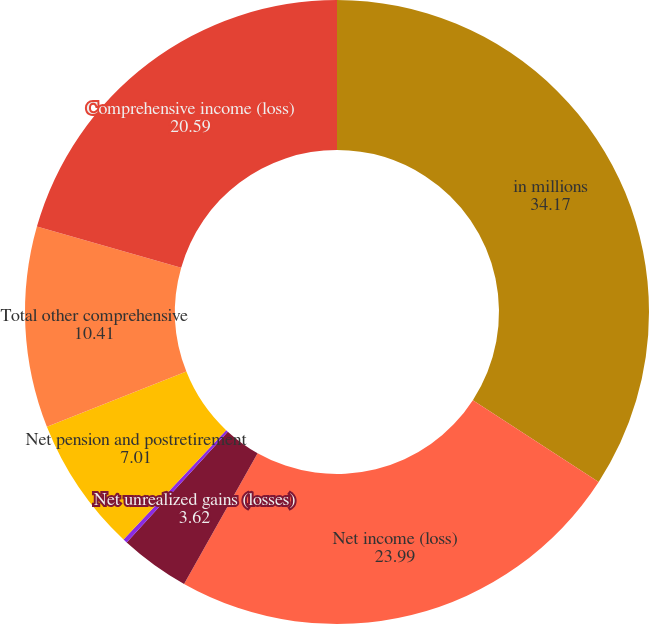Convert chart to OTSL. <chart><loc_0><loc_0><loc_500><loc_500><pie_chart><fcel>in millions<fcel>Net income (loss)<fcel>Net unrealized gains (losses)<fcel>Foreign currency translation<fcel>Net pension and postretirement<fcel>Total other comprehensive<fcel>Comprehensive income (loss)<nl><fcel>34.17%<fcel>23.99%<fcel>3.62%<fcel>0.22%<fcel>7.01%<fcel>10.41%<fcel>20.59%<nl></chart> 